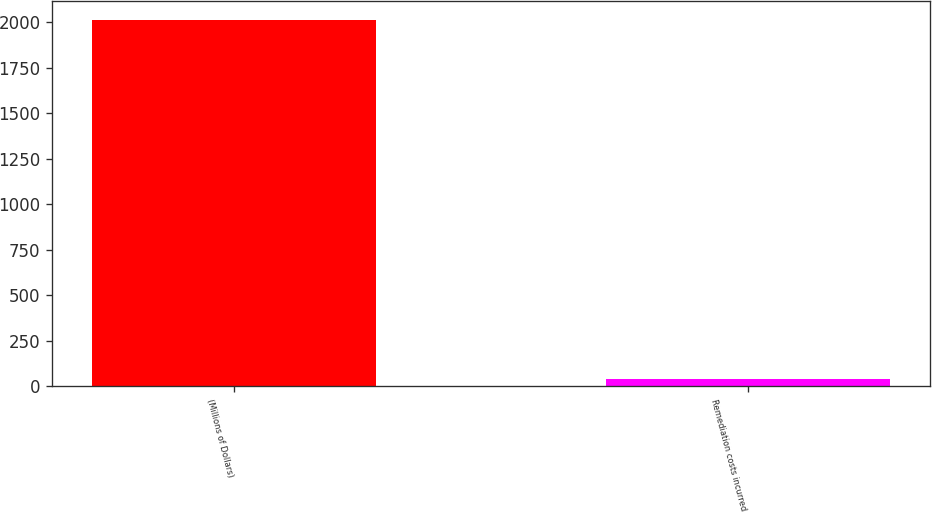Convert chart. <chart><loc_0><loc_0><loc_500><loc_500><bar_chart><fcel>(Millions of Dollars)<fcel>Remediation costs incurred<nl><fcel>2015<fcel>37<nl></chart> 